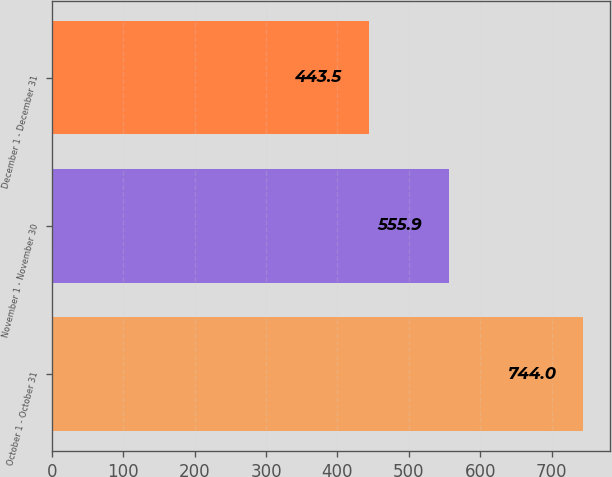<chart> <loc_0><loc_0><loc_500><loc_500><bar_chart><fcel>October 1 - October 31<fcel>November 1 - November 30<fcel>December 1 - December 31<nl><fcel>744<fcel>555.9<fcel>443.5<nl></chart> 